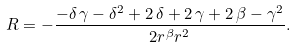Convert formula to latex. <formula><loc_0><loc_0><loc_500><loc_500>R = - \frac { - \delta \, \gamma - { \delta } ^ { 2 } + 2 \, \delta + 2 \, \gamma + 2 \, \beta - { \gamma } ^ { 2 } } { 2 { r } ^ { \beta } { r } ^ { 2 } } .</formula> 